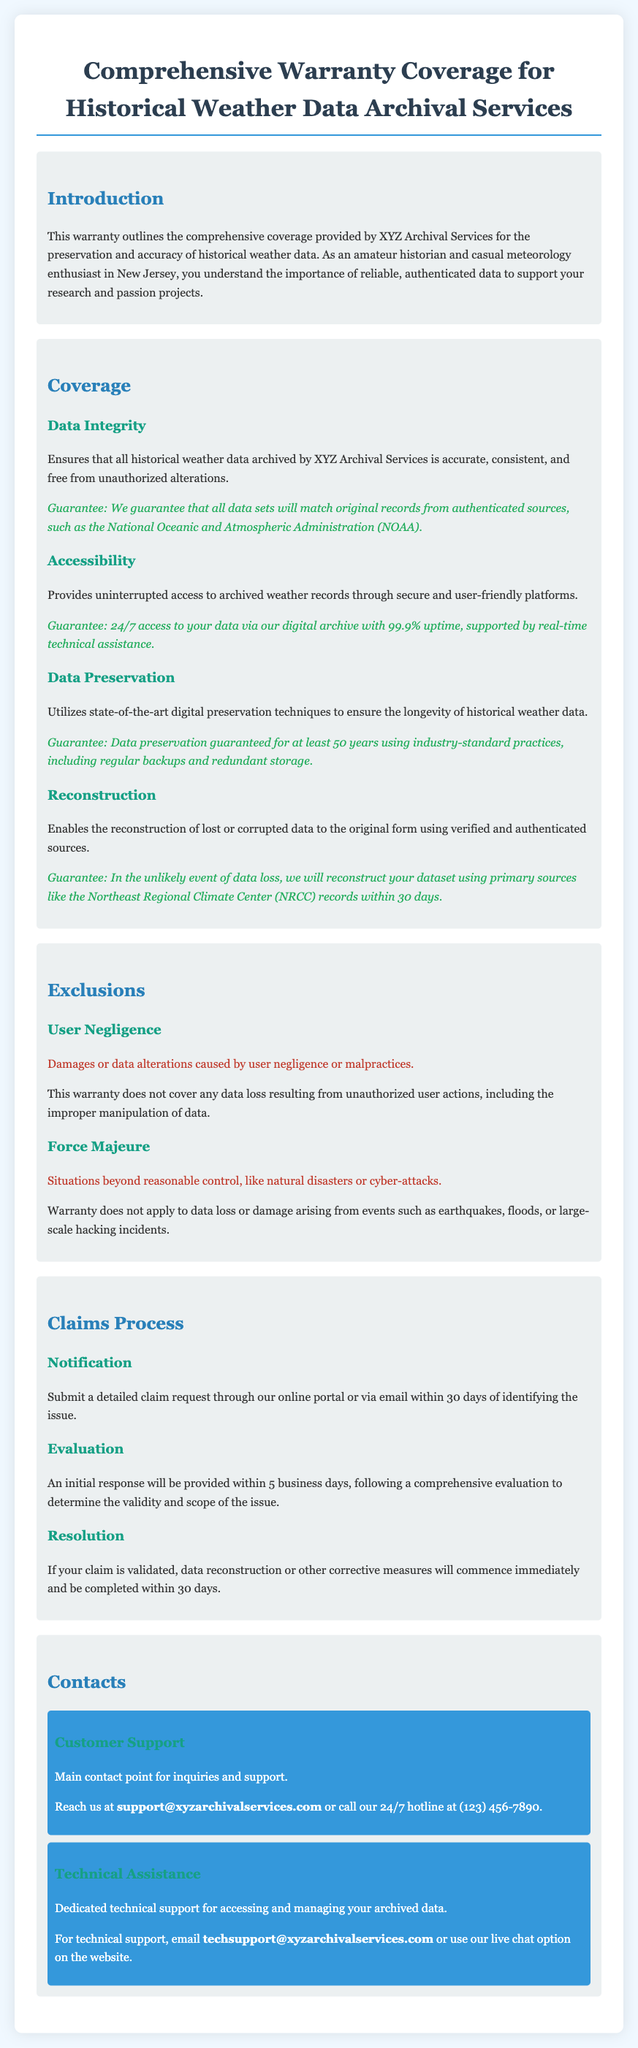What is the name of the service provider? The name of the service provider mentioned in the document is XYZ Archival Services.
Answer: XYZ Archival Services What is the guarantee for data preservation? The document states that data preservation is guaranteed for at least 50 years using industry-standard practices, including regular backups and redundant storage.
Answer: 50 years What is the uptime guarantee for data access? The warranty guarantees 24/7 access to data with a 99.9% uptime.
Answer: 99.9% What should you do to submit a claim? The document specifies that you should submit a detailed claim request through their online portal or via email within 30 days of identifying the issue.
Answer: Submit a detailed claim What events are excluded from the warranty coverage? The warranty excludes damages or data loss from situations like natural disasters or cyber-attacks, specifically mentioned as force majeure events.
Answer: Force majeure What is the initial response time for claim evaluation? According to the document, an initial response will be provided within 5 business days for claim evaluation.
Answer: 5 business days Within how many days will data reconstruction be completed if a claim is validated? The document mentions that data reconstruction or other corrective measures will be completed within 30 days if the claim is validated.
Answer: 30 days Who should be contacted for technical support? The document indicates that for technical support, you should contact techsupport@xyzarchivalservices.com or use their live chat option.
Answer: techsupport@xyzarchivalservices.com 